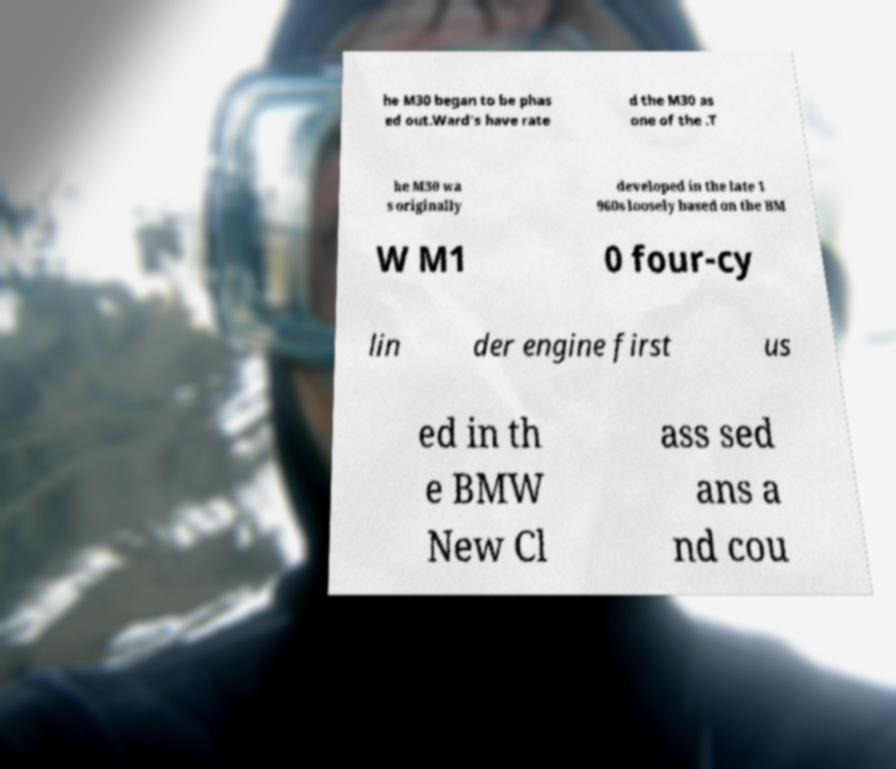Could you extract and type out the text from this image? he M30 began to be phas ed out.Ward's have rate d the M30 as one of the .T he M30 wa s originally developed in the late 1 960s loosely based on the BM W M1 0 four-cy lin der engine first us ed in th e BMW New Cl ass sed ans a nd cou 